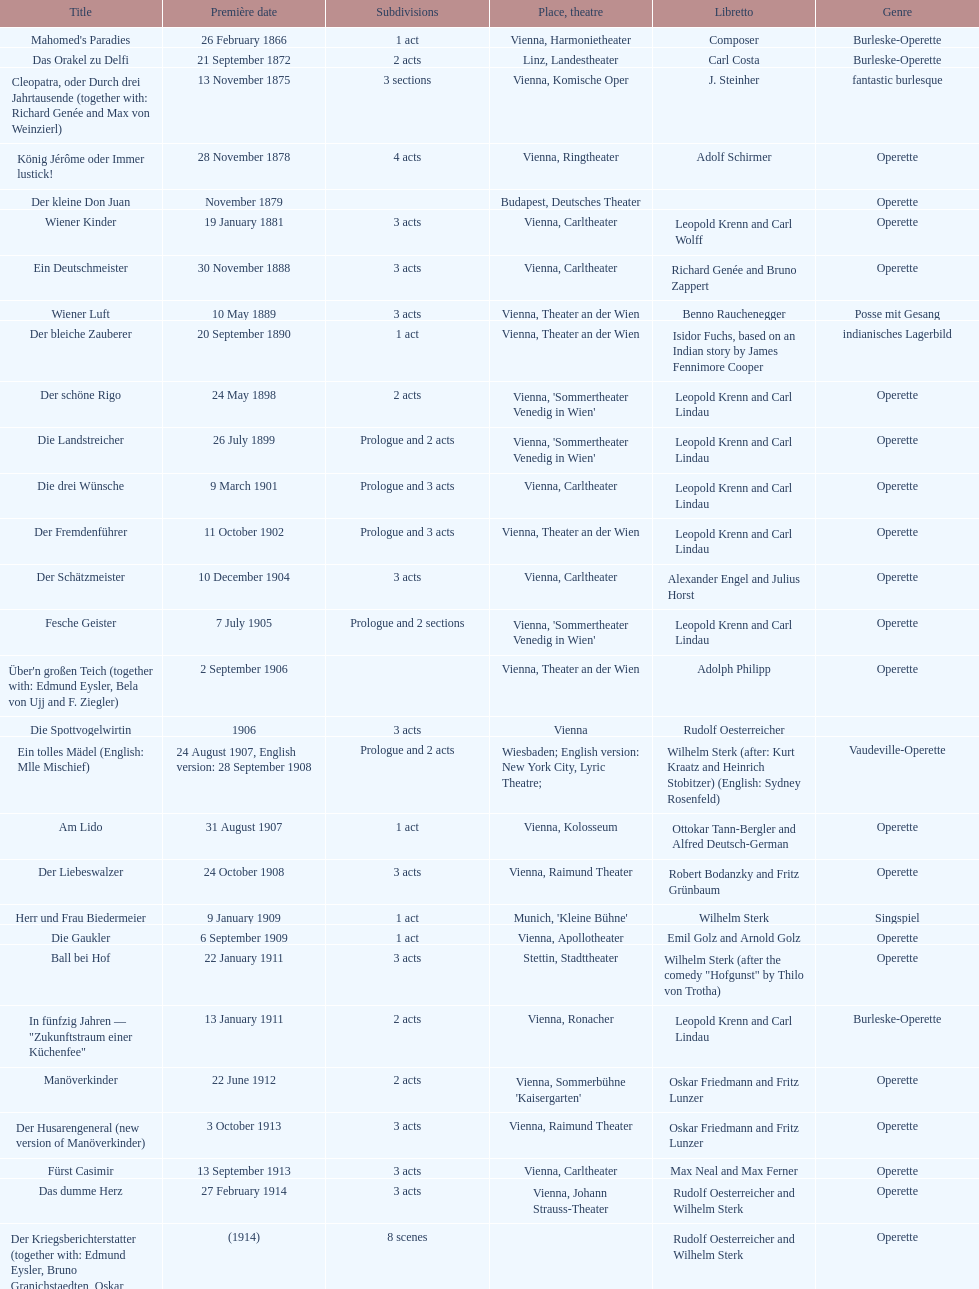What was the year of the last title? 1958. 